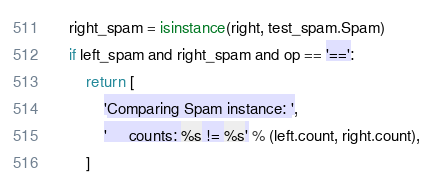<code> <loc_0><loc_0><loc_500><loc_500><_Python_>    right_spam = isinstance(right, test_spam.Spam)
    if left_spam and right_spam and op == '==':
        return [
            'Comparing Spam instance: ',
            '     counts: %s != %s' % (left.count, right.count),
        ]
</code> 